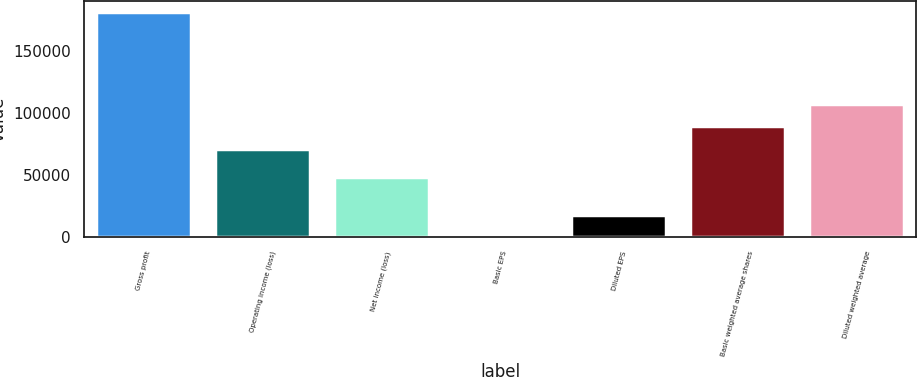<chart> <loc_0><loc_0><loc_500><loc_500><bar_chart><fcel>Gross profit<fcel>Operating income (loss)<fcel>Net income (loss)<fcel>Basic EPS<fcel>Diluted EPS<fcel>Basic weighted average shares<fcel>Diluted weighted average<nl><fcel>181532<fcel>71305<fcel>48336<fcel>0.58<fcel>18153.7<fcel>89458.1<fcel>107611<nl></chart> 